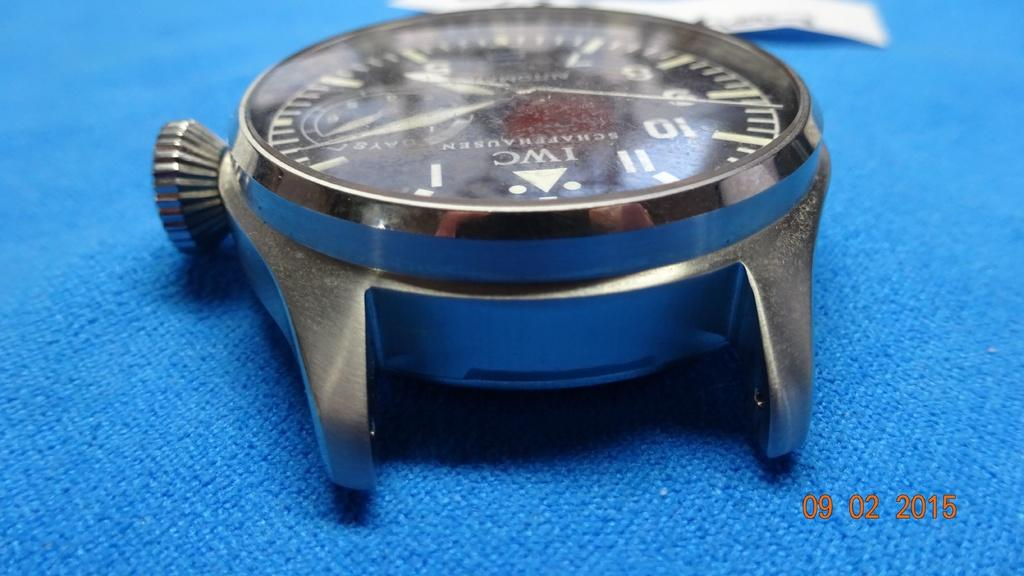<image>
Render a clear and concise summary of the photo. Face of a watch which has the letters "IWC" on it. 